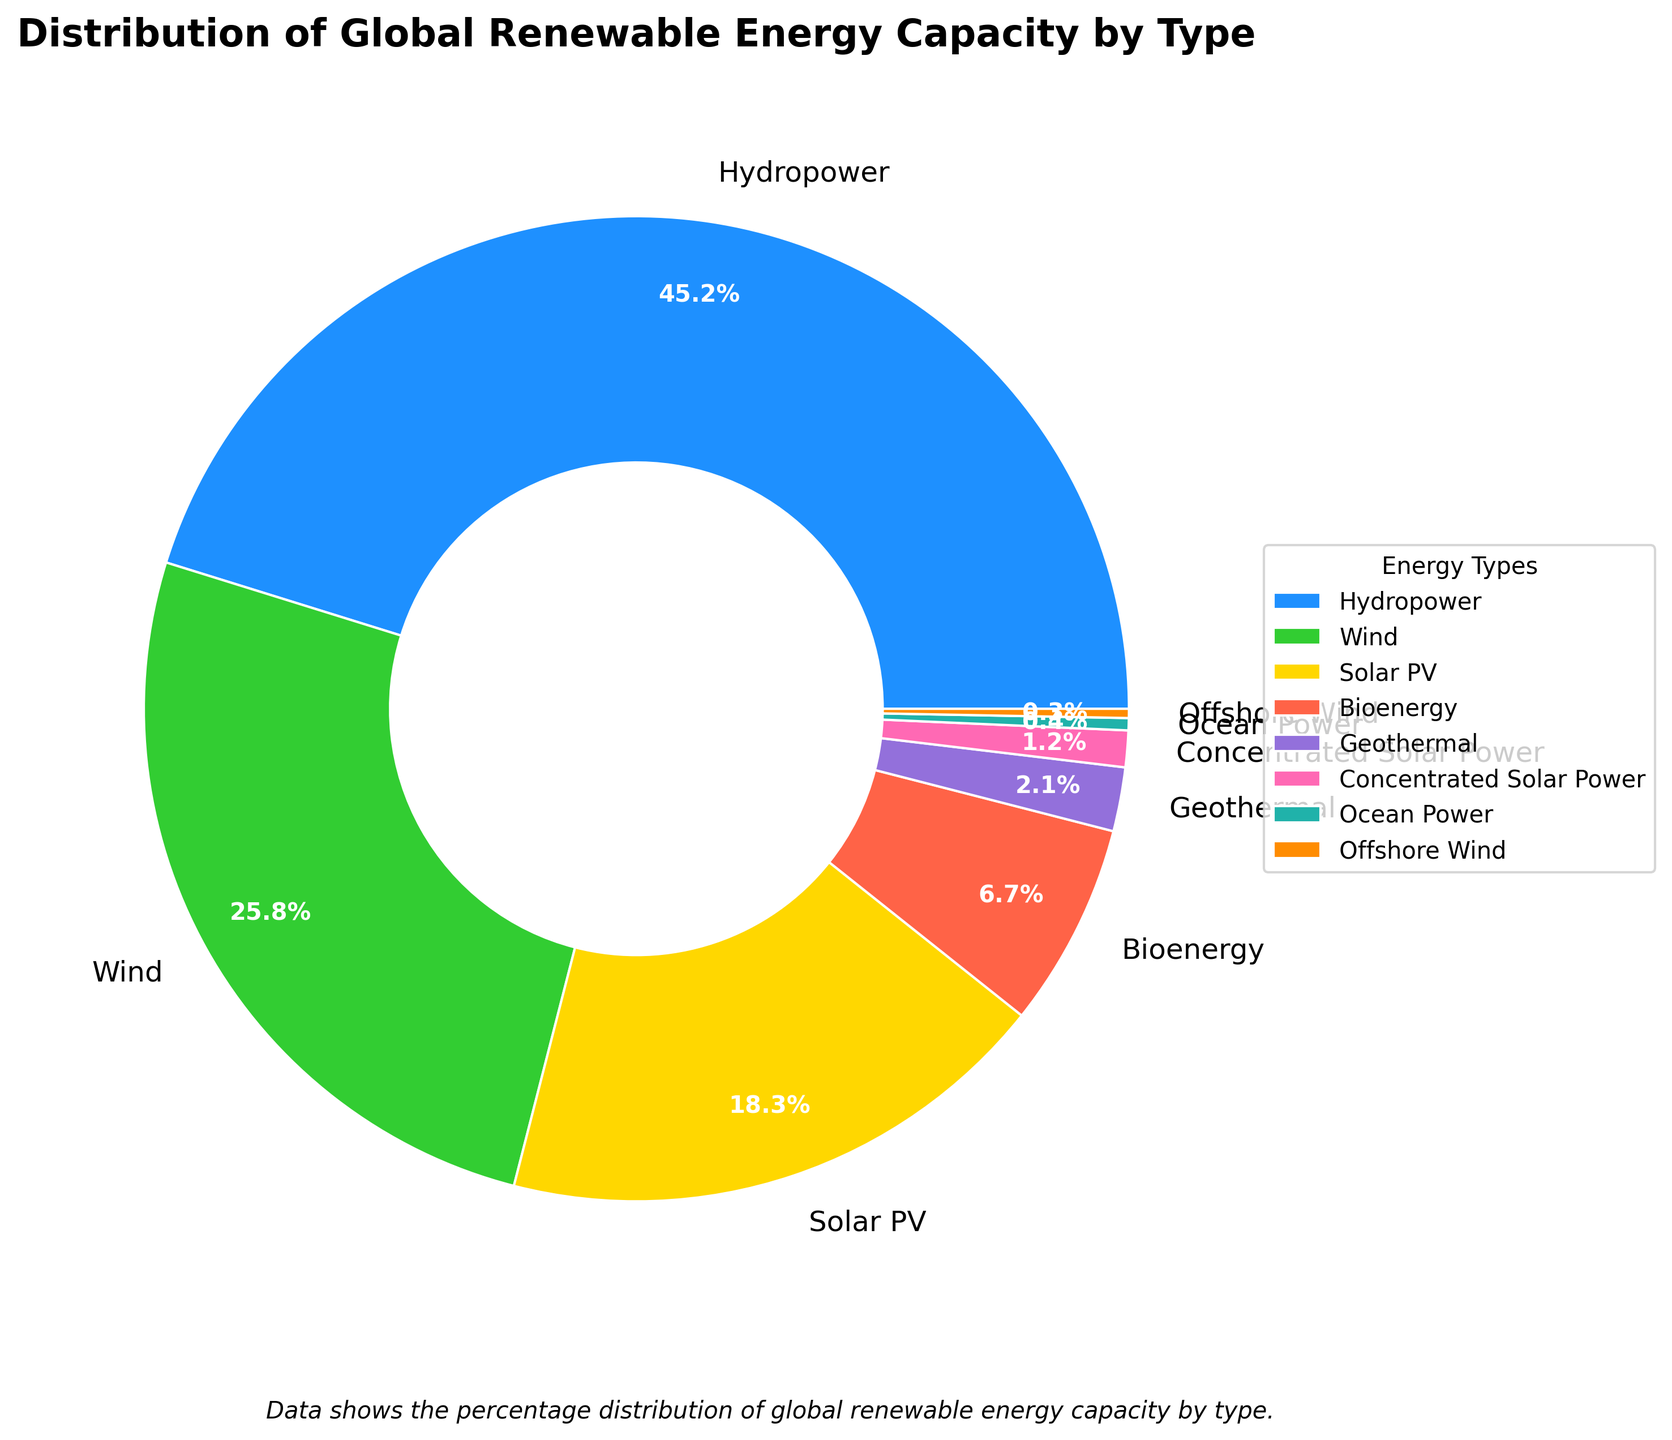What is the renewable energy source with the largest capacity? The pie chart shows the distribution of global renewable energy capacity by type. Hydropower has the largest slice of the pie chart, indicating it is the leading source.
Answer: Hydropower Which renewable energy sources together make up more than 50% of the global capacity? Hydropower (45.2%), when added to Wind (25.8%), gives a combined total of 71%, which is more than 50%.
Answer: Hydropower, Wind What is the total percentage of global renewable energy capacity from Solar PV and Wind? To find this, we sum the percentages for Solar PV (18.3%) and Wind (25.8%): 18.3% + 25.8% = 44.1%.
Answer: 44.1% Is the combined percentage of Bioenergy and Geothermal greater than the percentage of Solar PV? Bioenergy (6.7%) + Geothermal (2.1%) equals 8.8%. Solar PV is 18.3%, so 8.8% is not greater than 18.3%.
Answer: No How does the capacity of Offshore Wind compare to Ocean Power? The pie chart indicates Offshore Wind has 0.3% whereas Ocean Power has 0.4%. Thus, Offshore Wind is slightly smaller than Ocean Power.
Answer: Smaller What is the difference in the percentage capacity between the largest and smallest sources? The largest source is Hydropower (45.2%) and the smallest is Offshore Wind (0.3%). The difference is 45.2% - 0.3% = 44.9%.
Answer: 44.9% Which energy source is represented by the green slice in the chart? The green slice in the pie chart corresponds to Wind energy.
Answer: Wind What's the total percentage of the four smallest renewable energy sources? Summing the percentages for Ocean Power (0.4%), Offshore Wind (0.3%), Concentrated Solar Power (1.2%), and Geothermal (2.1%) gives 0.4% + 0.3% + 1.2% + 2.1% = 4%.
Answer: 4% Compare the visual sizes of Solar PV and Bioenergy slices. Which one is larger? The Solar PV slice is visually larger than the Bioenergy slice in the pie chart.
Answer: Solar PV What is the combined capacity percentage of Hydropower, Wind, and Solar PV? Summing the percentages for Hydropower (45.2%), Wind (25.8%), and Solar PV (18.3%) results in 45.2% + 25.8% + 18.3% = 89.3%.
Answer: 89.3% 